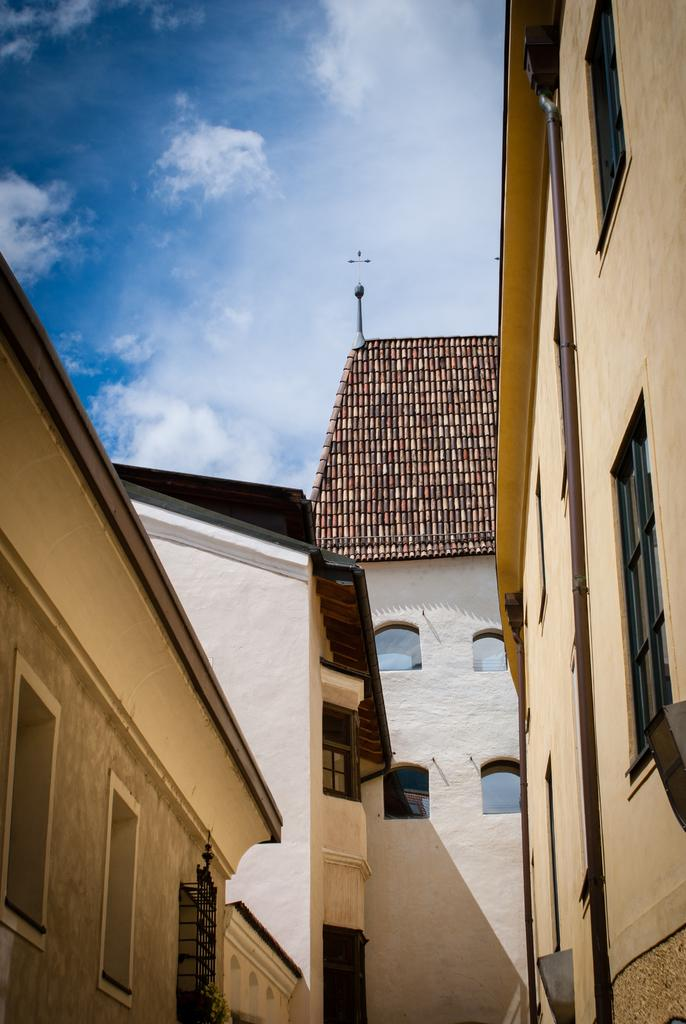What type of structures are present in the image? There are buildings in the image. What features can be observed on the buildings? The buildings have windows and pipes. Can you describe any additional elements on the buildings? There is a pole on one of the buildings. What can be seen in the background of the image? The sky is visible behind the buildings. How many sisters are standing next to the buildings in the image? There are no sisters present in the image; it only features buildings, windows, pipes, and a pole. What type of apple can be seen growing on the buildings in the image? There are no apples present in the image; the buildings have windows, pipes, and a pole, but no trees or plants. 